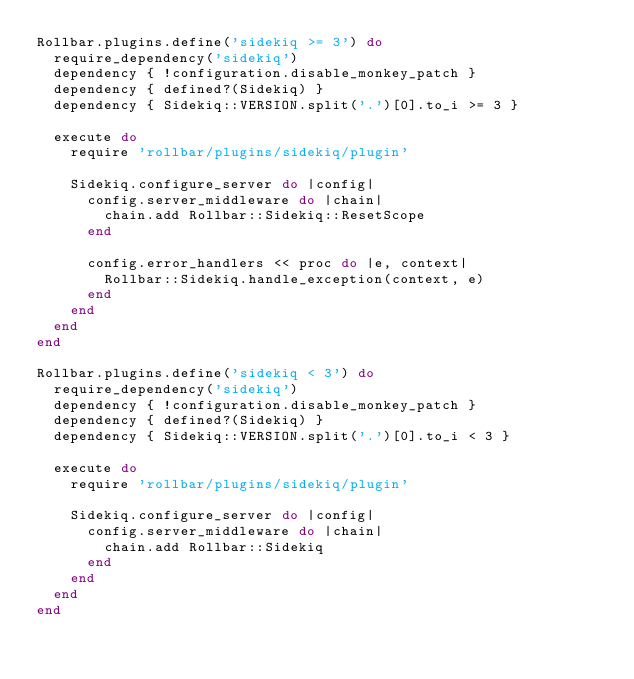<code> <loc_0><loc_0><loc_500><loc_500><_Ruby_>Rollbar.plugins.define('sidekiq >= 3') do
  require_dependency('sidekiq')
  dependency { !configuration.disable_monkey_patch }
  dependency { defined?(Sidekiq) }
  dependency { Sidekiq::VERSION.split('.')[0].to_i >= 3 }

  execute do
    require 'rollbar/plugins/sidekiq/plugin'

    Sidekiq.configure_server do |config|
      config.server_middleware do |chain|
        chain.add Rollbar::Sidekiq::ResetScope
      end

      config.error_handlers << proc do |e, context|
        Rollbar::Sidekiq.handle_exception(context, e)
      end
    end
  end
end

Rollbar.plugins.define('sidekiq < 3') do
  require_dependency('sidekiq')
  dependency { !configuration.disable_monkey_patch }
  dependency { defined?(Sidekiq) }
  dependency { Sidekiq::VERSION.split('.')[0].to_i < 3 }

  execute do
    require 'rollbar/plugins/sidekiq/plugin'

    Sidekiq.configure_server do |config|
      config.server_middleware do |chain|
        chain.add Rollbar::Sidekiq
      end
    end
  end
end
</code> 